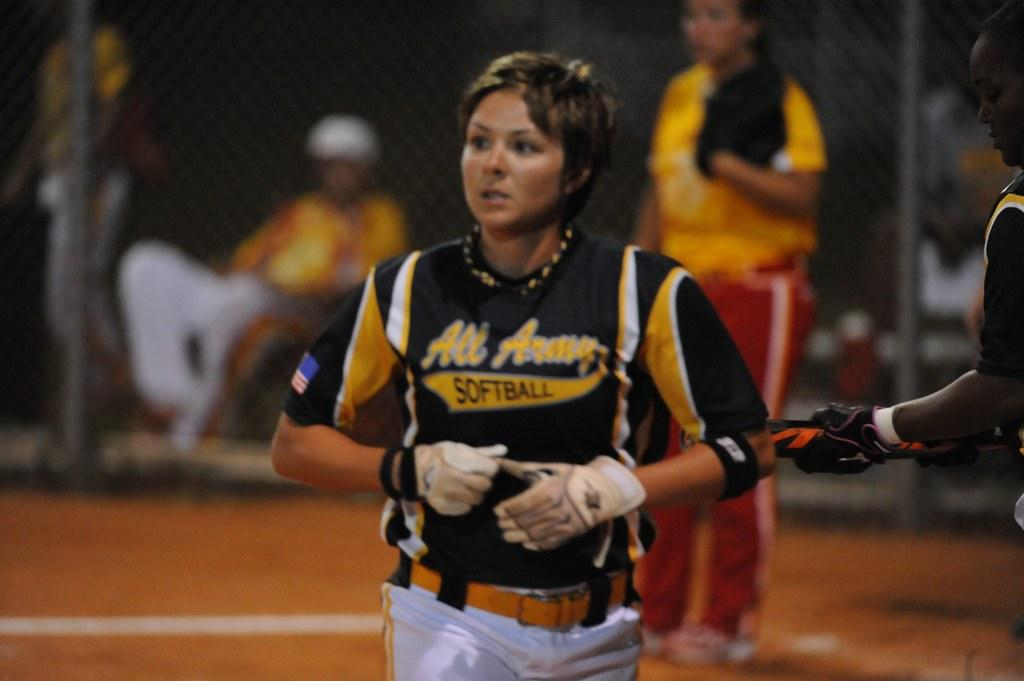Provide a one-sentence caption for the provided image. A woman athlete in her black and gold uniform with the word "softball" written on it. 